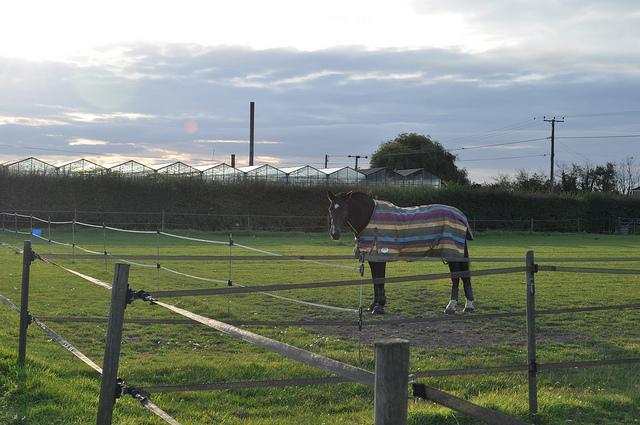What is the black strip across the horse's face?
Quick response, please. Bridle. What is different about one of the animals?
Answer briefly. Wearing blanket. Is this an open field?
Be succinct. No. How many horses are there?
Quick response, please. 1. Is there a blanket on the horse?
Short answer required. Yes. How do you call man jumping on a horse?
Give a very brief answer. You don't. What are the large poles for in the distance?
Quick response, please. Electricity. 